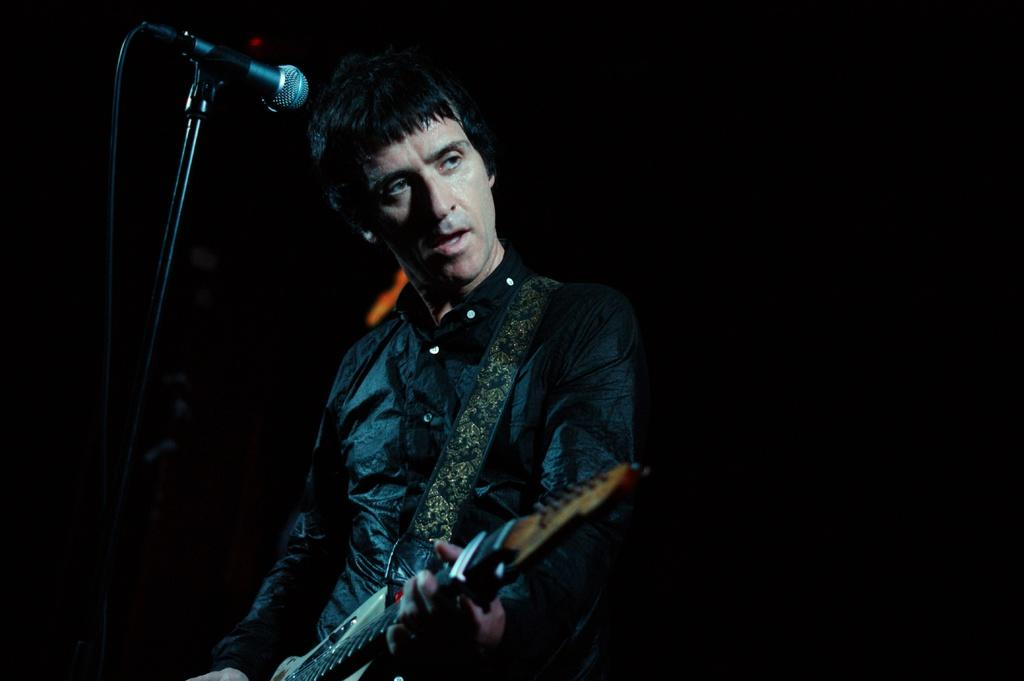Who is the main subject in the image? There is a man in the image. What is the man wearing? The man is wearing a black shirt. What object is the man holding? The man is holding a guitar. What is in front of the man? There is a microphone stand in front of the man. What activity is the man likely engaged in? It appears that the man is singing a song. What type of industry can be seen in the background of the image? There is no industry visible in the image; it primarily features the man and his musical equipment. 